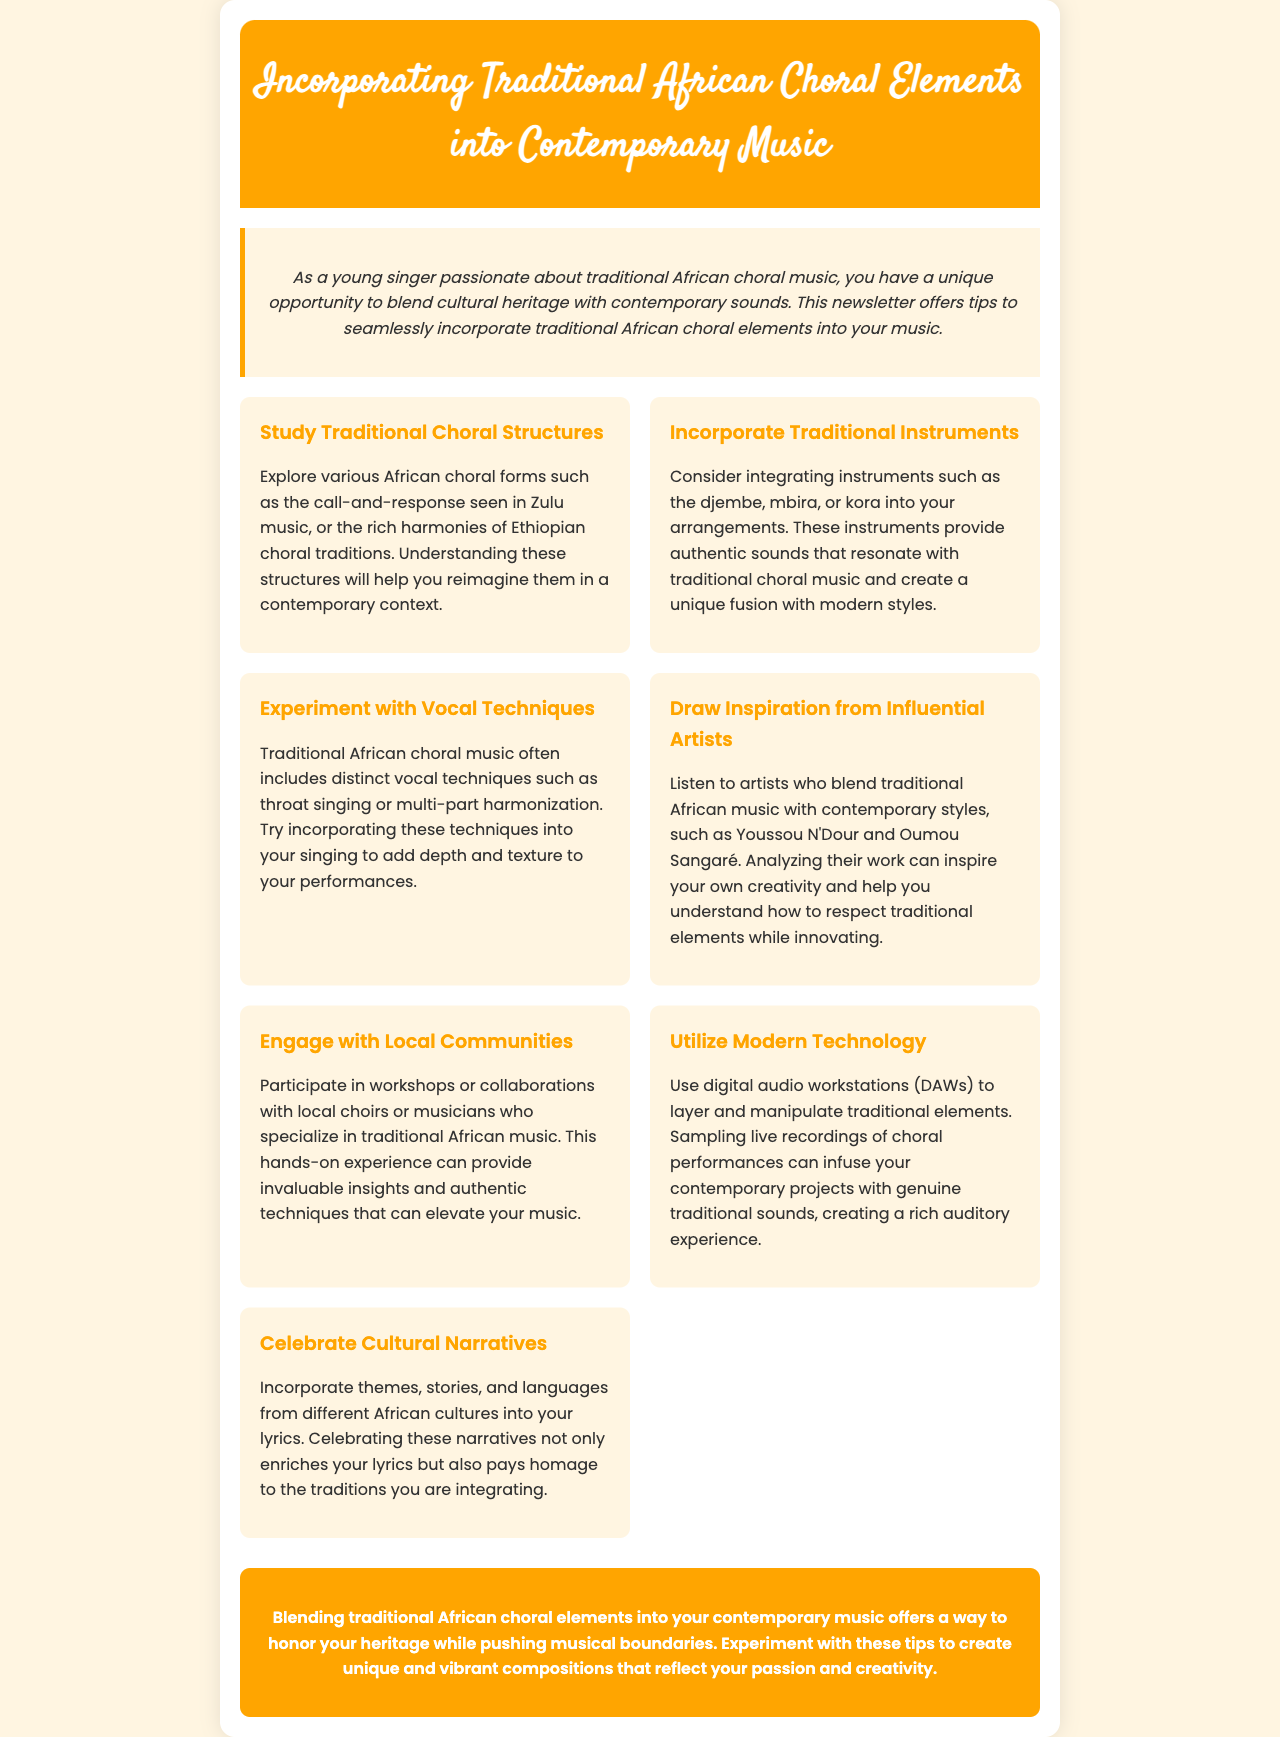What is the title of the newsletter? The title of the newsletter is located at the top of the document under the header.
Answer: Incorporating Traditional African Choral Elements into Contemporary Music How many tips are provided in the newsletter? The total number of tips can be counted in the tips section of the document.
Answer: Seven What is one traditional instrument suggested for incorporation? The document lists various traditional instruments; one example can be found in the corresponding tip.
Answer: Djembe Who are two influential artists mentioned for inspiration? The names of the artists can be found in the section discussing inspiration from influential artists.
Answer: Youssou N'Dour and Oumou Sangaré What vocal technique is suggested for experimentation? The tip section mentions specific vocal techniques that can be experimented with.
Answer: Throat singing What is the primary theme of the newsletter? The overall aim and focus of the newsletter are articulated in the introductory paragraph.
Answer: Blending traditional African choral elements with contemporary music What color is used for the header background? The color of the header is specified in the document's styling information.
Answer: Orange 